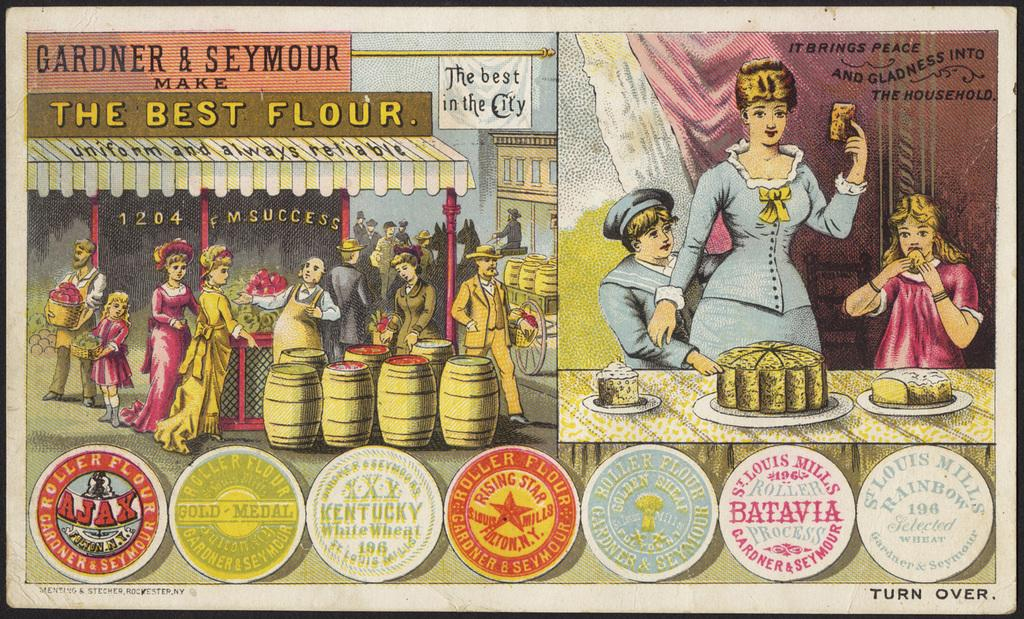<image>
Share a concise interpretation of the image provided. an old advertisement for the best flour has women and cake 